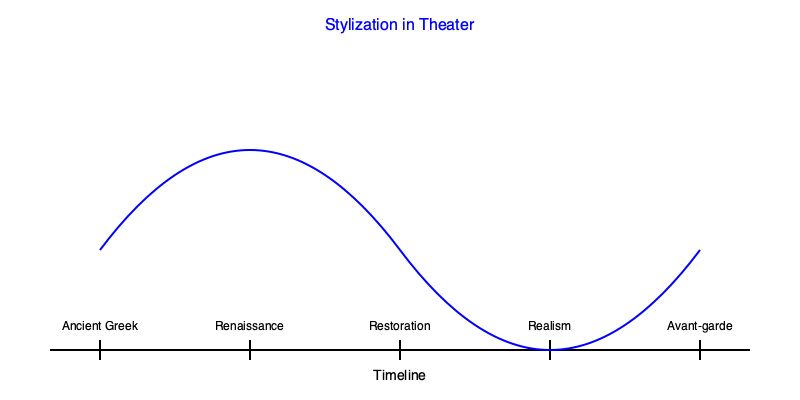Based on the timeline of theatrical styles shown in the graph, which period marked a significant shift towards more naturalistic performances, contrasting with the highly stylized acting of earlier eras? To answer this question, let's analyze the evolution of theatrical styles as depicted in the timeline:

1. Ancient Greek theater: Known for its highly stylized performances, including the use of masks and formalized movement.

2. Renaissance theater: While more varied than Ancient Greek, it still maintained a degree of stylization, especially in comedies and tragedies.

3. Restoration theater: This period saw a slight move towards more natural performances, but still retained many stylized elements.

4. Realism: This marks a significant shift in theatrical style. The curve in the graph dips sharply here, indicating a move away from stylization.

5. Avant-garde: While innovative, this style often reintroduced elements of stylization, albeit in new forms.

The question asks about a shift towards more naturalistic performances. Looking at the timeline and the curve representing stylization, we can see that the most significant dip occurs at the "Realism" period. This indicates a move away from stylization and towards more naturalistic performances.

Realism in theater, which emerged in the late 19th and early 20th centuries, aimed to represent life on stage as closely as possible to reality. This contrasted sharply with the more stylized acting of earlier periods, making it the correct answer to this question.
Answer: Realism 